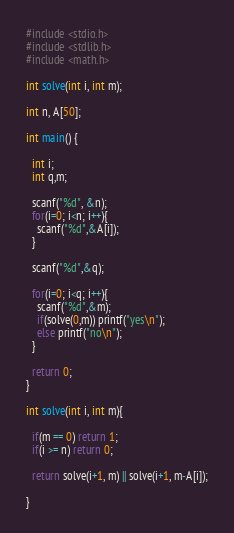<code> <loc_0><loc_0><loc_500><loc_500><_C_>#include <stdio.h>
#include <stdlib.h>
#include <math.h>

int solve(int i, int m);

int n, A[50];

int main() {

  int i;
  int q,m;

  scanf("%d", &n);
  for(i=0; i<n; i++){
    scanf("%d",&A[i]);
  }

  scanf("%d",&q);
  
  for(i=0; i<q; i++){
    scanf("%d",&m);
    if(solve(0,m)) printf("yes\n");
    else printf("no\n");
  }

  return 0;
}

int solve(int i, int m){

  if(m == 0) return 1;
  if(i >= n) return 0;

  return solve(i+1, m) || solve(i+1, m-A[i]);

}

</code> 